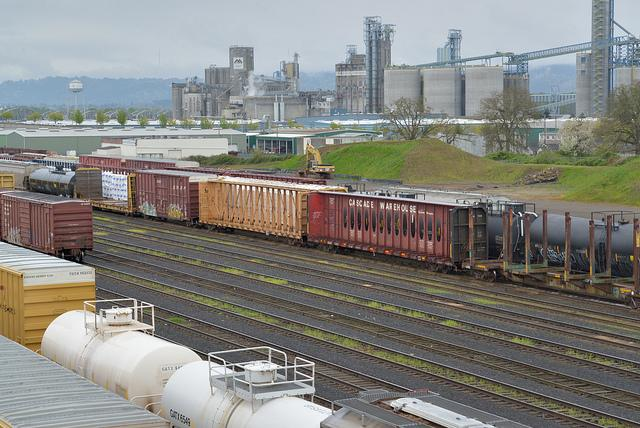What vehicles are here? Please explain your reasoning. trains. The vehicle is the only one that requires tracks to move. 